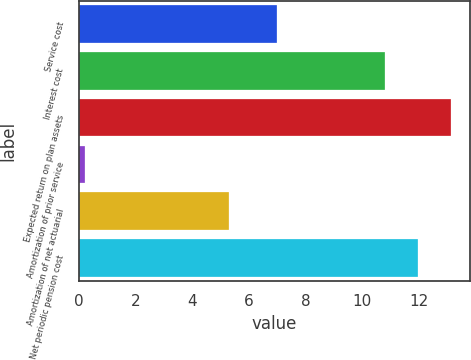<chart> <loc_0><loc_0><loc_500><loc_500><bar_chart><fcel>Service cost<fcel>Interest cost<fcel>Expected return on plan assets<fcel>Amortization of prior service<fcel>Amortization of net actuarial<fcel>Net periodic pension cost<nl><fcel>7<fcel>10.8<fcel>13.16<fcel>0.2<fcel>5.3<fcel>11.98<nl></chart> 